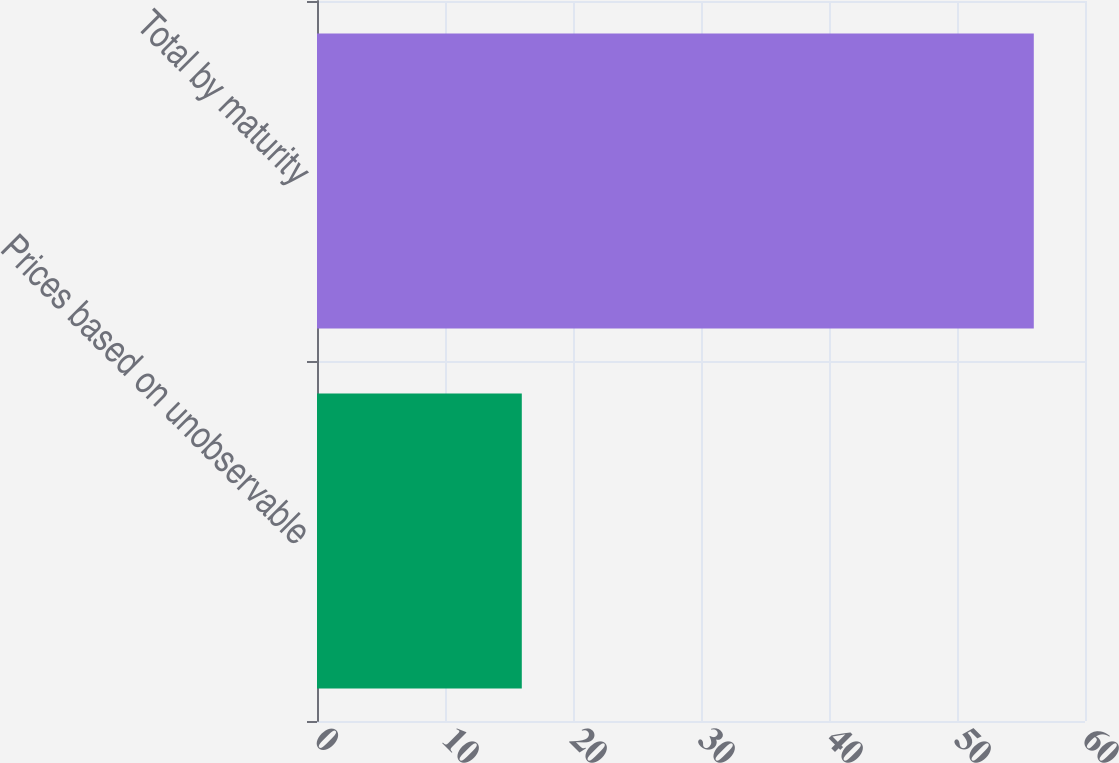Convert chart to OTSL. <chart><loc_0><loc_0><loc_500><loc_500><bar_chart><fcel>Prices based on unobservable<fcel>Total by maturity<nl><fcel>16<fcel>56<nl></chart> 